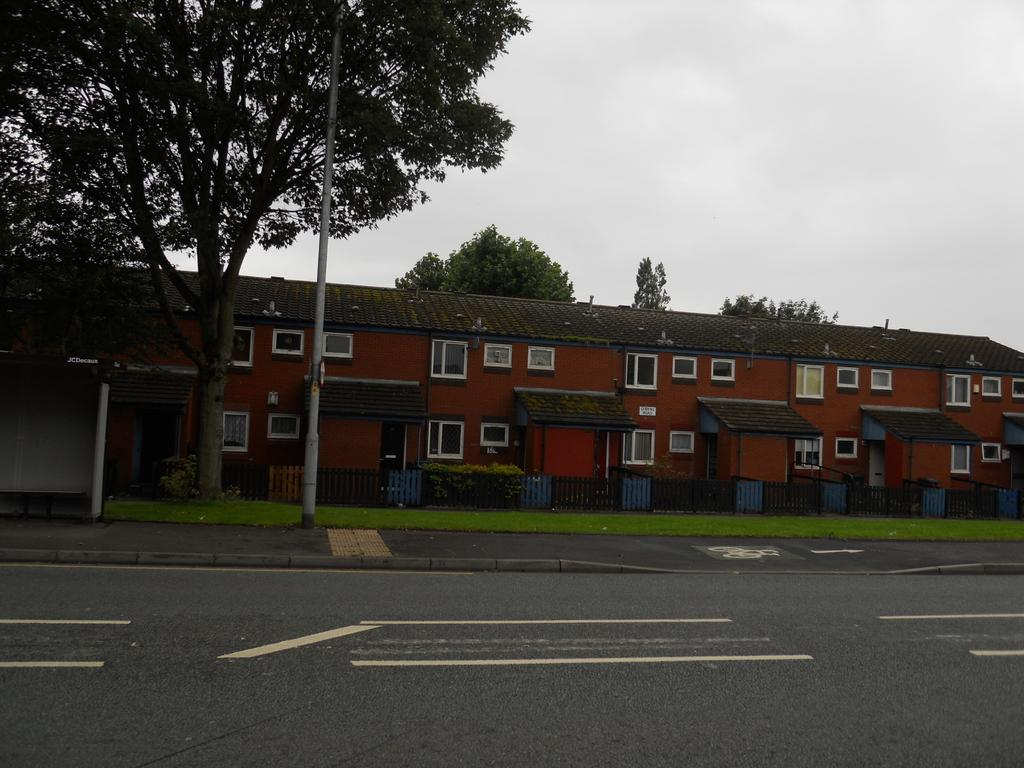What type of vegetation can be seen in the background of the image? There are trees in the background of the image. What type of structure is visible in the background of the image? There is a building in the background of the image. What is covering the ground in the image? There is grass on the ground in the image. What is separating the grassy area from another part of the image? There is a fence in the image. What is the condition of the sky in the image? The sky is cloudy in the image. Where is the mailbox located in the image? There is no mailbox present in the image. What idea does the cracker represent in the image? There is no cracker present in the image, so it cannot represent any idea. 